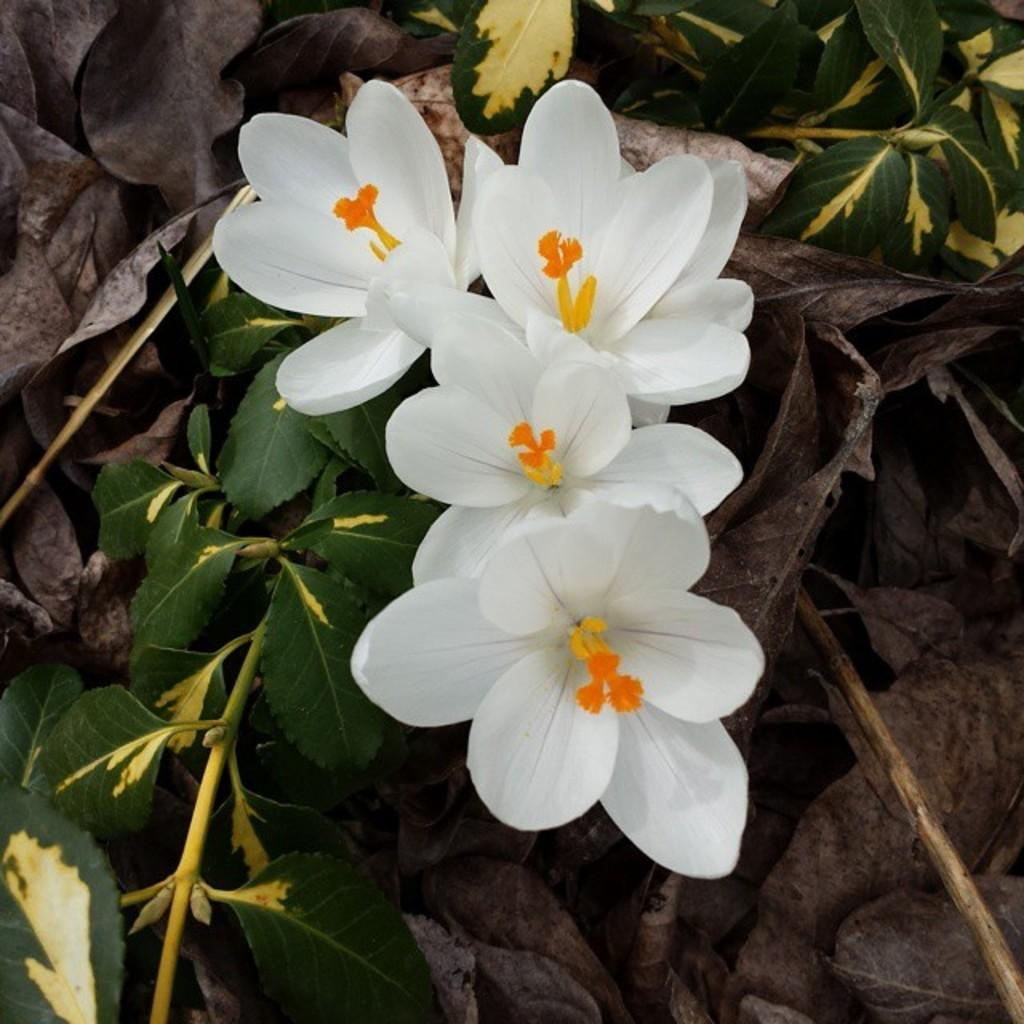What type of flowers are in the image? There is a group of white flowers on a stem in the image. Where are the flowers located? The flowers are on a plant. What can be seen in the background of the image? There are dried leaves in the background of the image. What type of amusement can be seen in the image? There is no amusement present in the image; it features a group of white flowers on a stem, a plant, and dried leaves in the background. 